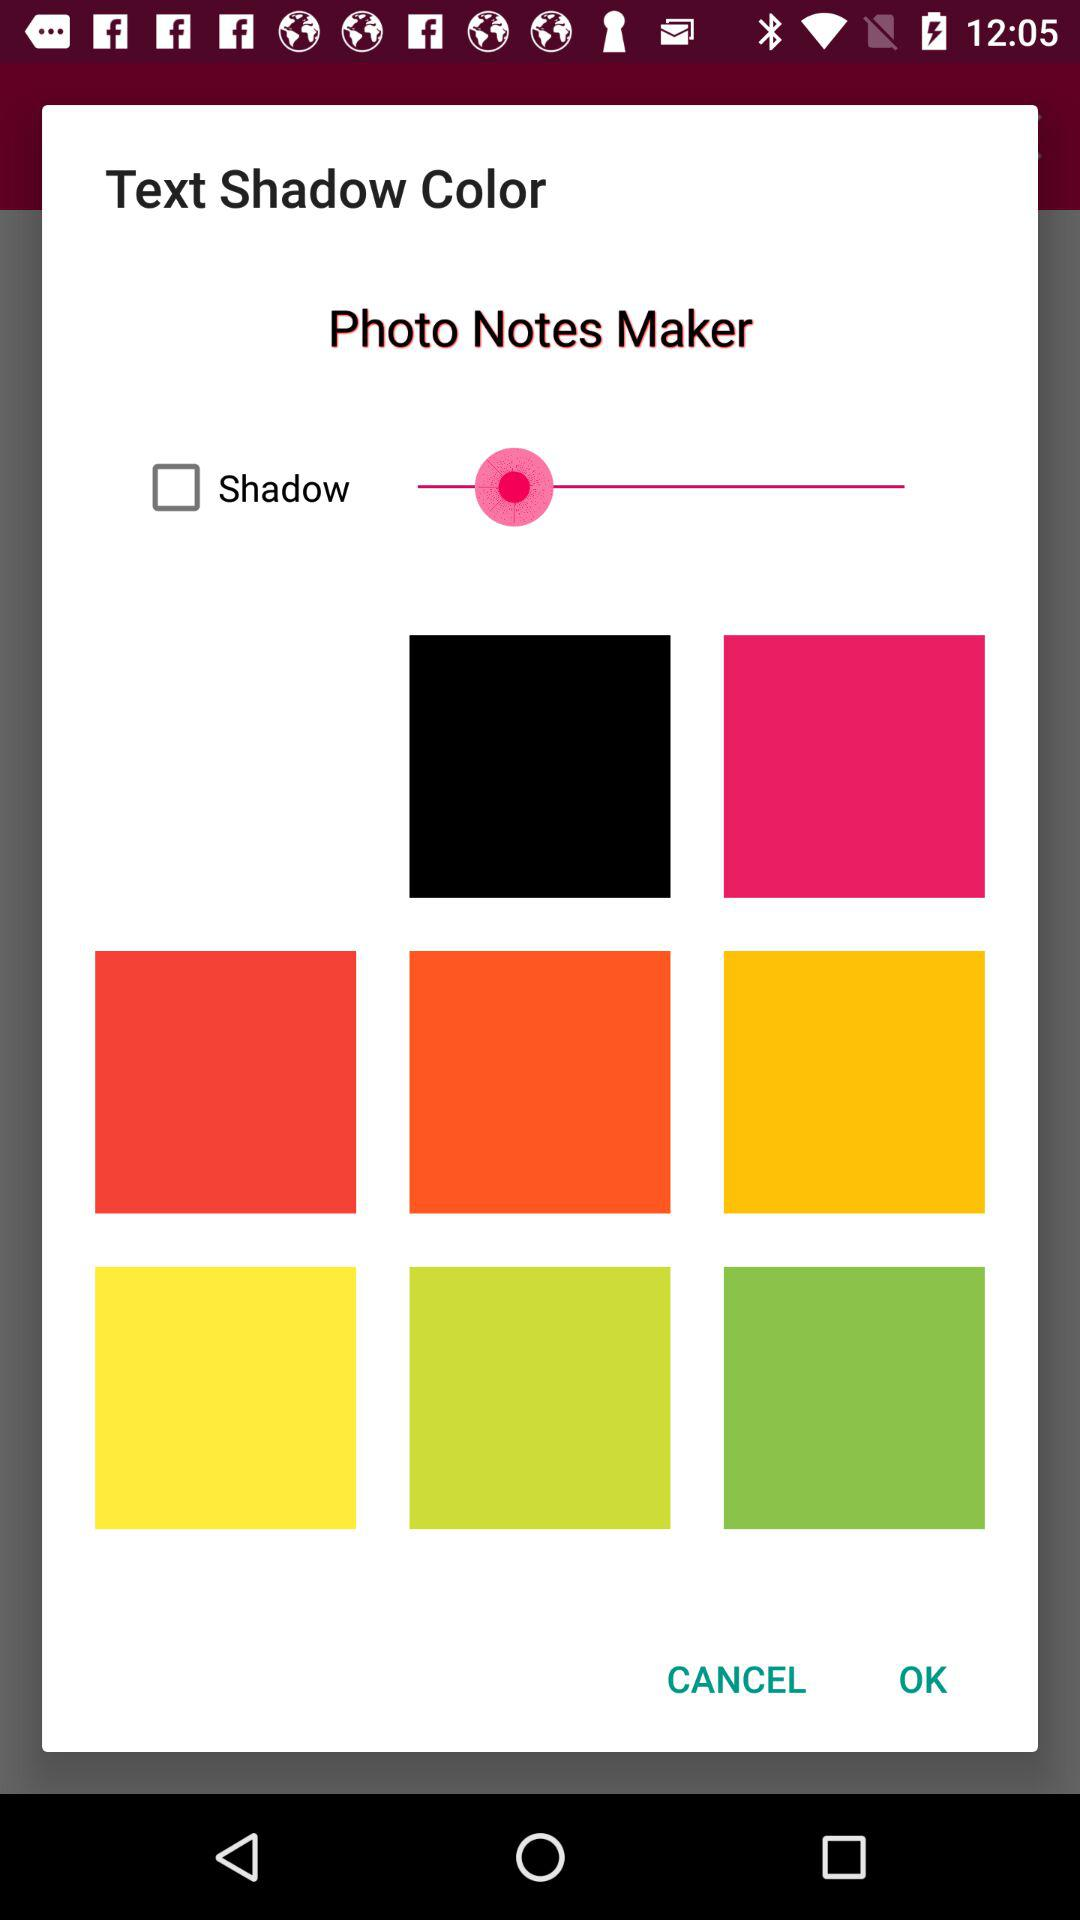How many different colors are represented in the six squares?
Answer the question using a single word or phrase. 6 